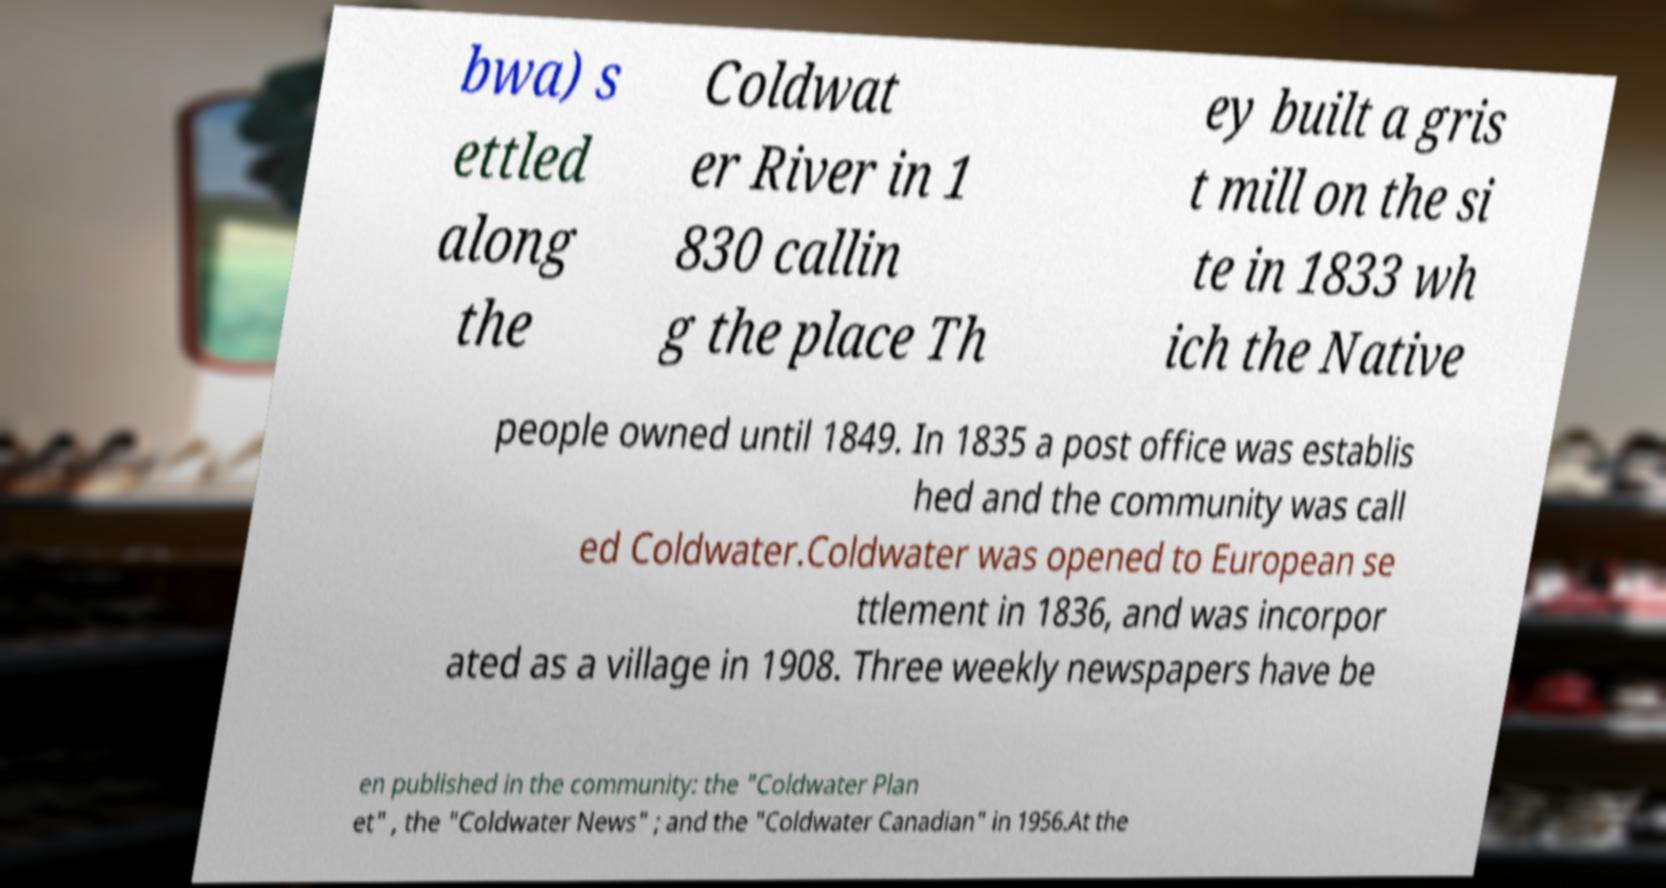There's text embedded in this image that I need extracted. Can you transcribe it verbatim? bwa) s ettled along the Coldwat er River in 1 830 callin g the place Th ey built a gris t mill on the si te in 1833 wh ich the Native people owned until 1849. In 1835 a post office was establis hed and the community was call ed Coldwater.Coldwater was opened to European se ttlement in 1836, and was incorpor ated as a village in 1908. Three weekly newspapers have be en published in the community: the "Coldwater Plan et" , the "Coldwater News" ; and the "Coldwater Canadian" in 1956.At the 